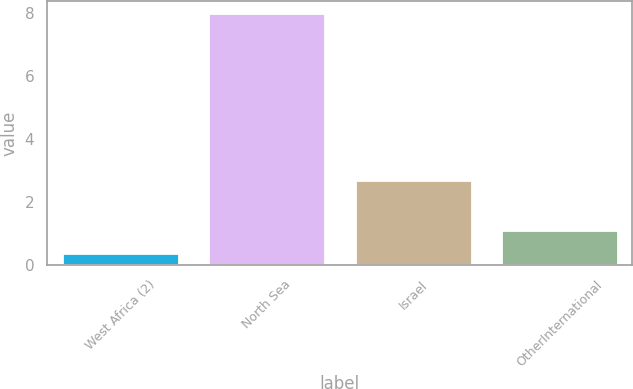Convert chart to OTSL. <chart><loc_0><loc_0><loc_500><loc_500><bar_chart><fcel>West Africa (2)<fcel>North Sea<fcel>Israel<fcel>OtherInternational<nl><fcel>0.37<fcel>8<fcel>2.72<fcel>1.13<nl></chart> 